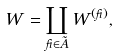<formula> <loc_0><loc_0><loc_500><loc_500>W = \coprod _ { \beta \in \tilde { A } } W ^ { ( \beta ) } ,</formula> 